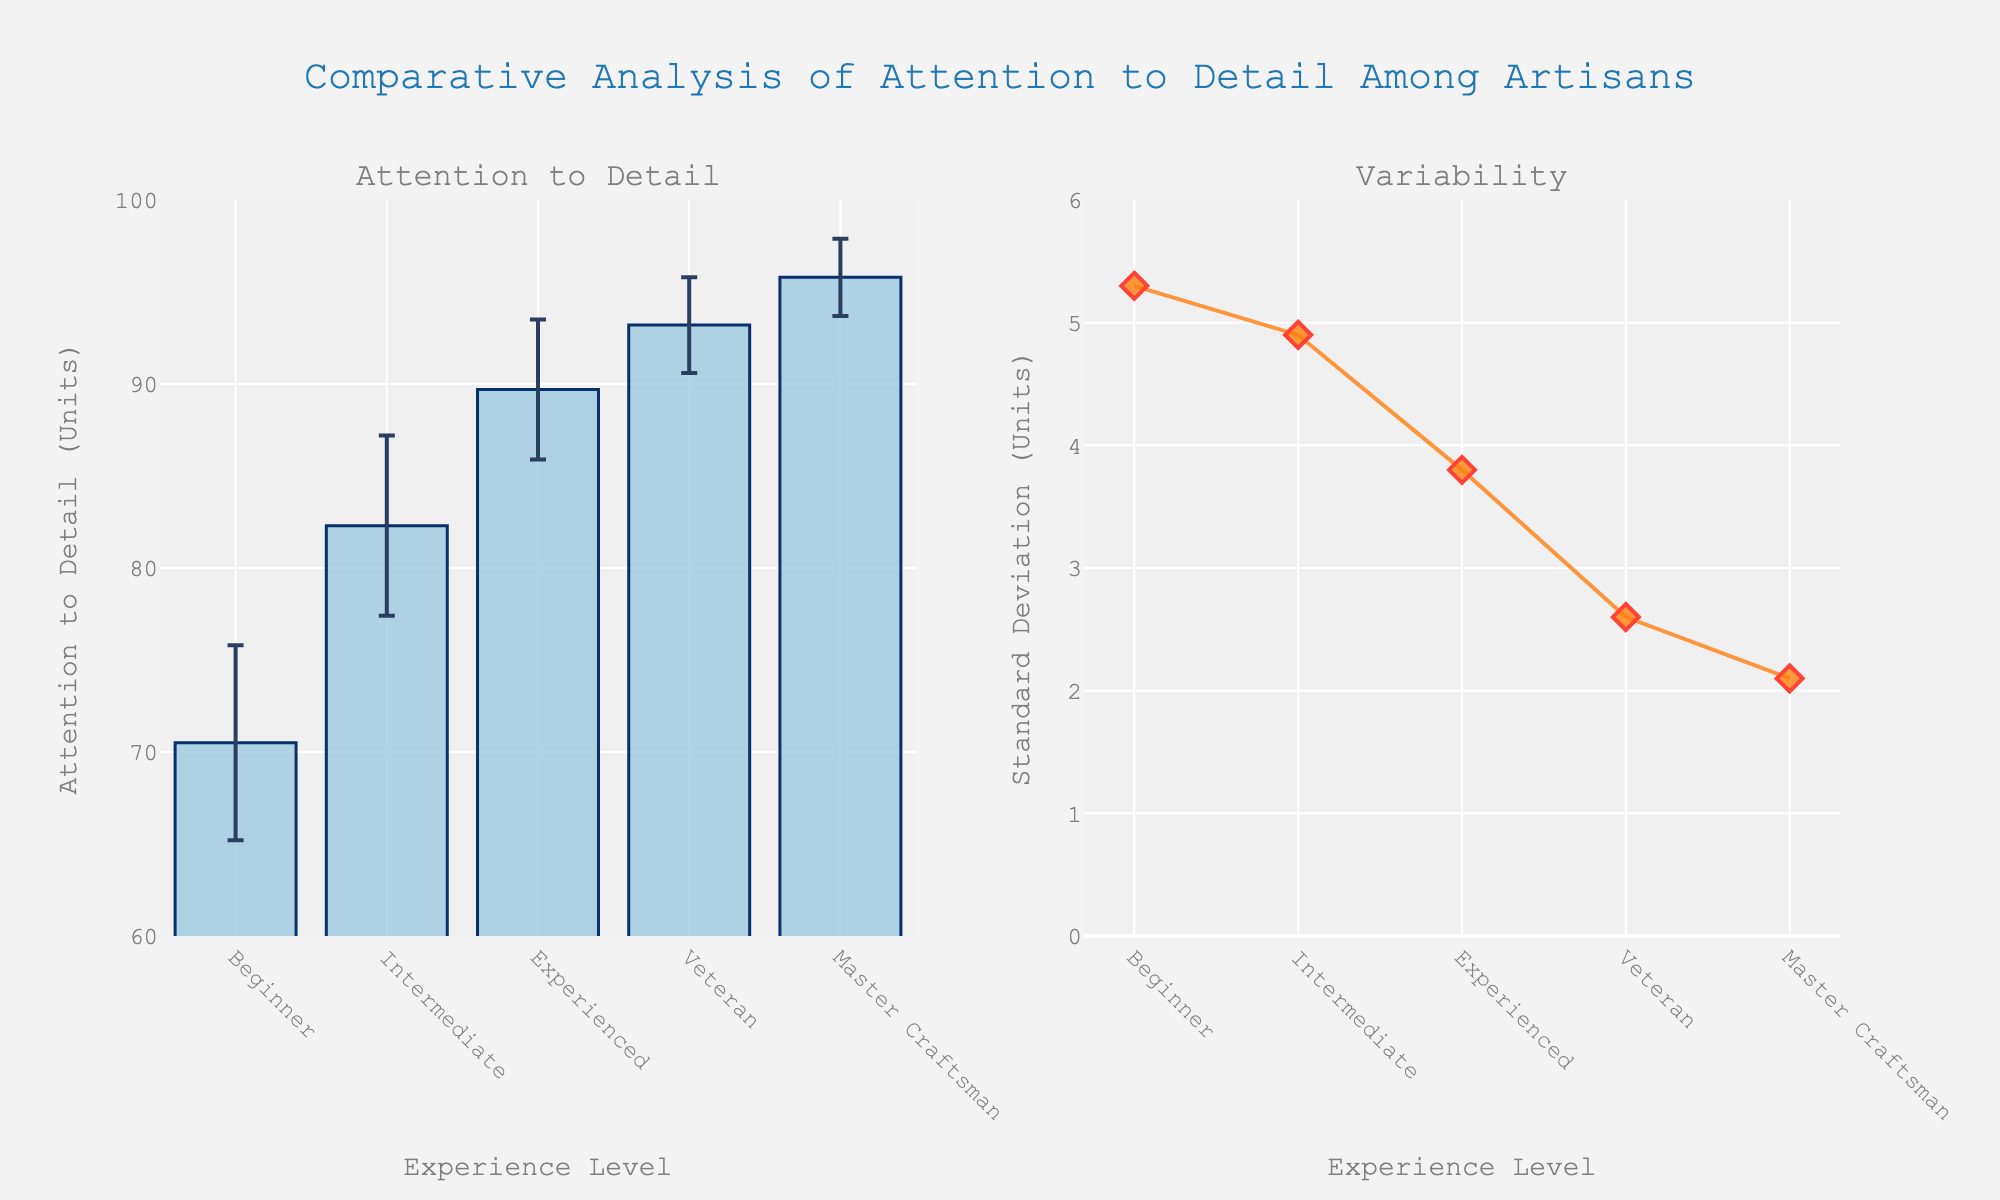What is the title of the figure? The title of the figure appears at the top center of the figure. It reads "Comparative Analysis of Attention to Detail Among Artisans."
Answer: Comparative Analysis of Attention to Detail Among Artisans What experience level shows the highest average attention to detail? By examining the left plot, which is a bar chart of average attention to detail, the highest bar corresponds to the "Master Craftsman" experience level.
Answer: Master Craftsman What is the range of attention to detail units on the left y-axis? The left y-axis of the bar chart ranges from 60 to 100 units of attention to detail.
Answer: 60 to 100 Which experience level has the largest variability in attention to detail? The scatter plot on the right shows the standard deviation of attention to detail, where the highest point corresponds to the "Beginner" experience level.
Answer: Beginner How does the attention to detail of an Experienced artisan compare to that of an Intermediate one? By comparing the bars on the left plot, an "Experienced" artisan has a higher attention to detail, with an average of 89.7 units, compared to 82.3 units for the "Intermediate" level.
Answer: Experienced has higher attention to detail What is the approximate difference in average attention to detail between the "Beginner" and "Veteran" experience levels? Subtract the average attention to detail of "Beginner" (70.5 units) from "Veteran" (93.2 units) using the left bar chart. The difference is 93.2 - 70.5 = 22.7 units.
Answer: 22.7 units What trend can be observed in the standard deviation of attention to detail as the experience level increases? By looking at the scatter plot on the right, the standard deviation decreases as the experience level increases, indicating less variability among more experienced artisans.
Answer: Decreases Which two experience levels have the smallest difference in average attention to detail, and what is this difference? Compare bars on the left plot, the "Veteran" (93.2 units) and "Master Craftsman" (95.8 units) have the smallest difference: 95.8 - 93.2 = 2.6 units.
Answer: Veteran and Master Craftsman; 2.6 units What's the average variability (standard deviation) in attention to detail for the Intermediate and Experienced levels? The standard deviations for "Intermediate" and "Experienced" levels are 4.9 and 3.8 units respectively. Calculate the average: (4.9 + 3.8) / 2 = 4.35 units.
Answer: 4.35 units 